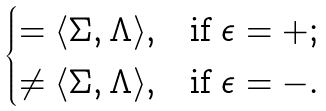<formula> <loc_0><loc_0><loc_500><loc_500>\begin{cases} = \langle \Sigma , \Lambda \rangle , & \text {if $\epsilon=+$} ; \\ \neq \langle \Sigma , \Lambda \rangle , & \text {if $\epsilon=-$} . \end{cases}</formula> 